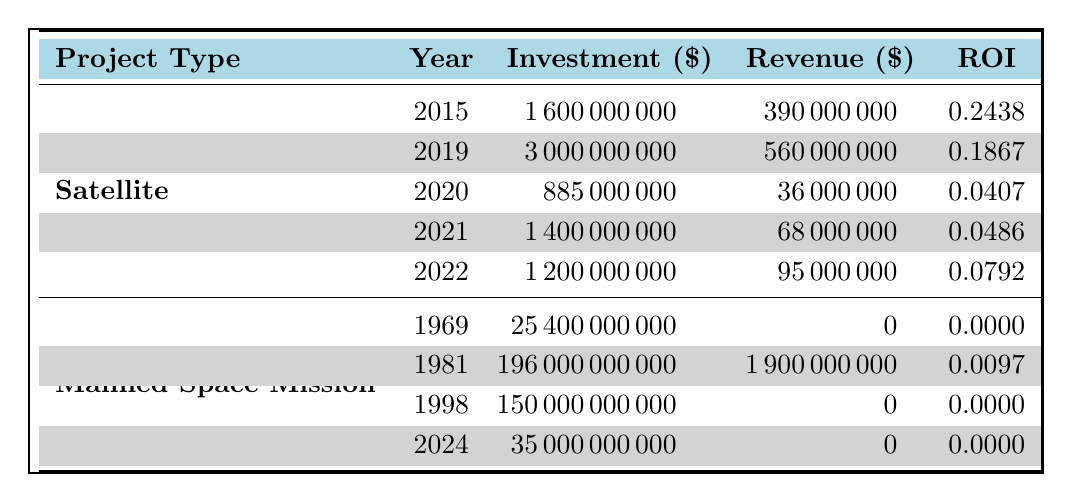What is the highest ROI among the satellite projects? The table lists the ROI for each satellite project. Comparing them, Inmarsat Global Xpress has the highest ROI of 0.2438.
Answer: 0.2438 Which manned space mission had the lowest investment? The table shows that the Apollo Program had an investment of $25,400,000,000, which is less than the investments of the other manned space missions listed.
Answer: 25,400,000,000 How many satellite projects have an ROI greater than 0.05? Reviewing the ROI values for satellite projects, I find that Inmarsat Global Xpress (0.2438), Iridium NEXT (0.1867), and O3b mPOWER (0.0792) have ROI greater than 0.05. This makes it a total of 3 satellite projects.
Answer: 3 What is the total investment for all manned space missions? The investments for all manned space missions listed are $25,400,000,000 (Apollo Program) + $196,000,000,000 (Space Shuttle Program) + $150,000,000,000 (International Space Station) + $35,000,000,000 (Artemis Program), leading to a total investment of $406,400,000,000.
Answer: 406,400,000,000 Is the Space Shuttle Program's ROI higher than that of the Starlink project? The Space Shuttle Program has an ROI of 0.0097 while the Starlink project has an ROI of 0.0407. Comparing the two values, Space Shuttle Program's ROI is less than that of Starlink.
Answer: No What is the average ROI of manned space missions? The ROI values for manned space missions are 0 (Apollo Program), 0.0097 (Space Shuttle Program), 0 (International Space Station), and 0 (Artemis Program). To find the average, I calculate the sum of these values: 0 + 0.0097 + 0 + 0 = 0.0097, and then divide by the number of missions (4), resulting in an average ROI of 0.002425.
Answer: 0.002425 Which satellite project was launched in 2020 and what was its ROI? The table indicates that Starlink is the only satellite project launched in 2020, and it has an ROI of 0.0407.
Answer: Starlink, 0.0407 Do all manned space missions show a positive ROI? Looking at the ROI values for each manned space mission, I see that the Apollo Program, International Space Station, and Artemis Program all have an ROI of 0, which is not positive. Therefore, not all manned space missions show a positive ROI.
Answer: No 